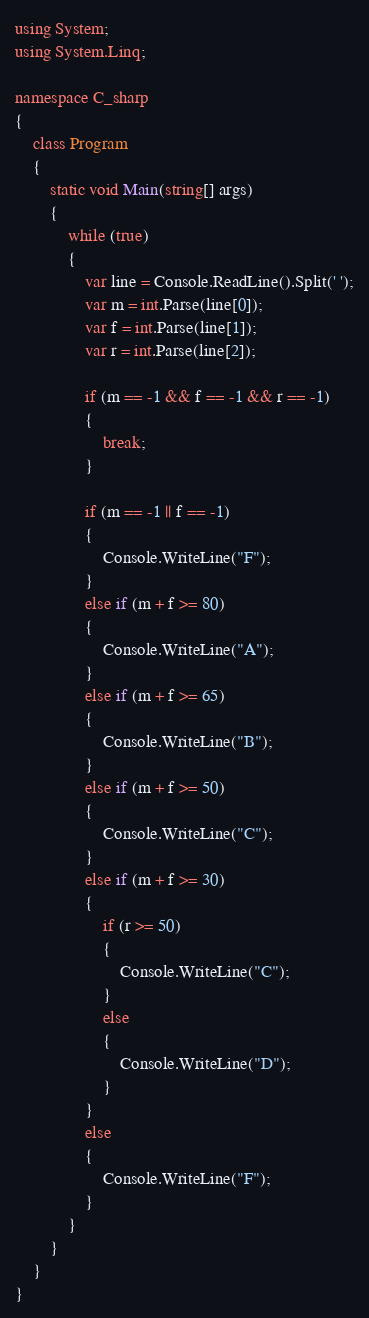Convert code to text. <code><loc_0><loc_0><loc_500><loc_500><_C#_>using System;
using System.Linq;

namespace C_sharp
{
    class Program
    {
        static void Main(string[] args)
        {
            while (true)
            {
                var line = Console.ReadLine().Split(' ');
                var m = int.Parse(line[0]);
                var f = int.Parse(line[1]);
                var r = int.Parse(line[2]);

                if (m == -1 && f == -1 && r == -1)
                {
                    break;
                }

                if (m == -1 || f == -1)
                {
                    Console.WriteLine("F");
                }
                else if (m + f >= 80)
                {
                    Console.WriteLine("A");
                }
                else if (m + f >= 65)
                {
                    Console.WriteLine("B");
                }
                else if (m + f >= 50)
                {
                    Console.WriteLine("C");
                }
                else if (m + f >= 30)
                {
                    if (r >= 50)
                    {
                        Console.WriteLine("C");
                    }
                    else
                    {
                        Console.WriteLine("D");
                    }
                }
                else
                {
                    Console.WriteLine("F");
                }
            }
        }
    }
}

</code> 